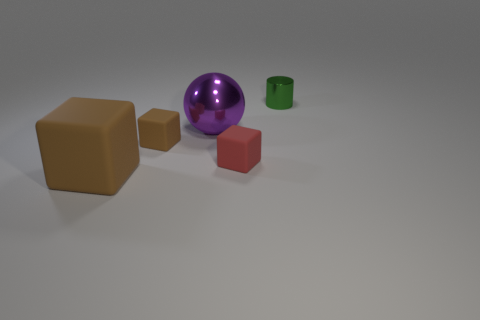Add 4 small red matte cubes. How many objects exist? 9 Subtract all spheres. How many objects are left? 4 Subtract all green things. Subtract all tiny cyan balls. How many objects are left? 4 Add 1 small green things. How many small green things are left? 2 Add 3 tiny purple matte balls. How many tiny purple matte balls exist? 3 Subtract 0 blue blocks. How many objects are left? 5 